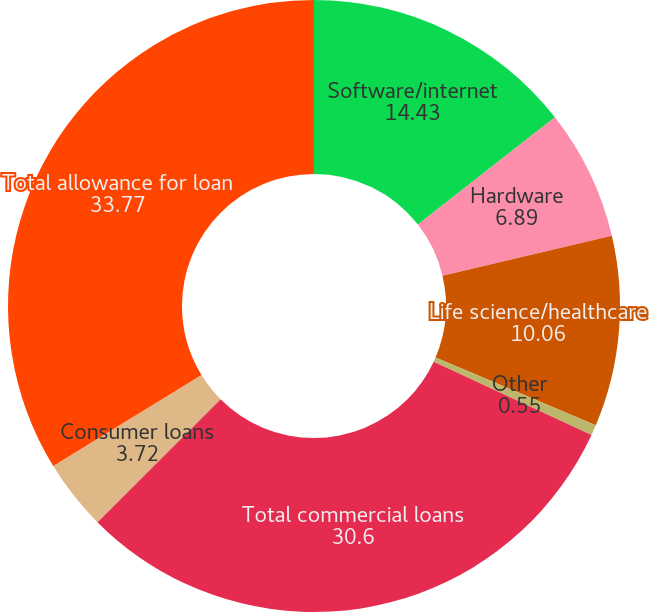Convert chart to OTSL. <chart><loc_0><loc_0><loc_500><loc_500><pie_chart><fcel>Software/internet<fcel>Hardware<fcel>Life science/healthcare<fcel>Other<fcel>Total commercial loans<fcel>Consumer loans<fcel>Total allowance for loan<nl><fcel>14.43%<fcel>6.89%<fcel>10.06%<fcel>0.55%<fcel>30.6%<fcel>3.72%<fcel>33.77%<nl></chart> 